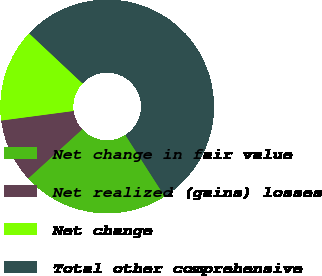Convert chart. <chart><loc_0><loc_0><loc_500><loc_500><pie_chart><fcel>Net change in fair value<fcel>Net realized (gains) losses<fcel>Net change<fcel>Total other comprehensive<nl><fcel>22.32%<fcel>9.66%<fcel>14.09%<fcel>53.93%<nl></chart> 